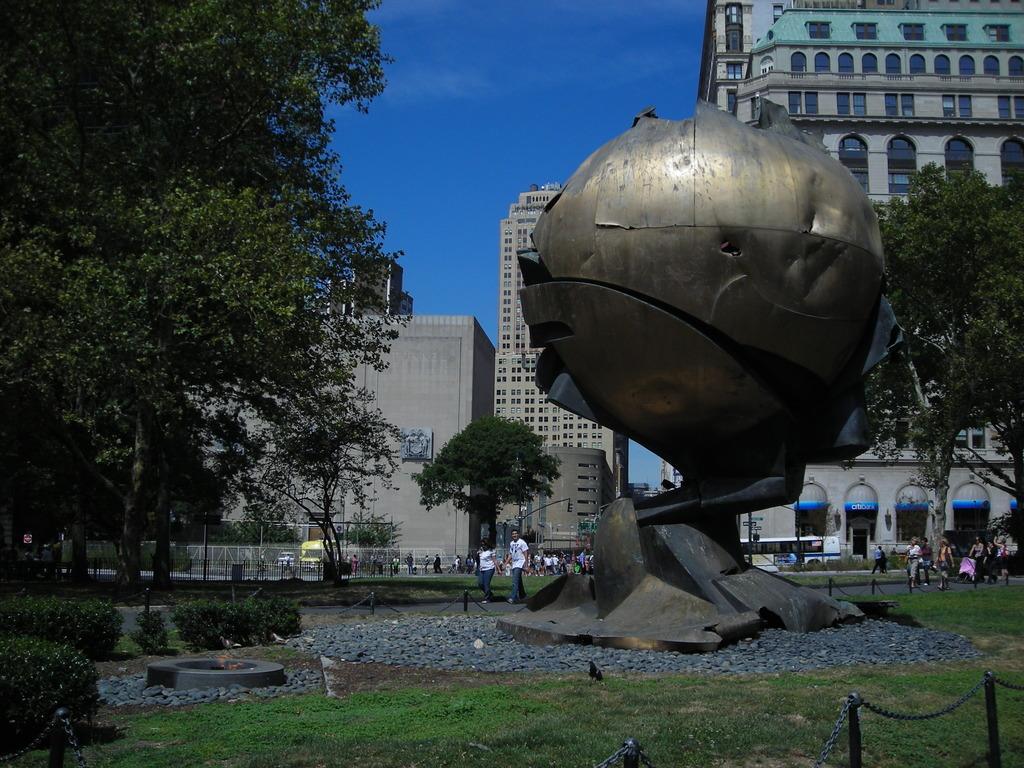Describe this image in one or two sentences. In the background we can see the sky, buildings, people, railings, poles, people. In this picture we can see the trees, plants, pebbles and the fence. This picture is mainly highlighted with a metal circular sculpture. 